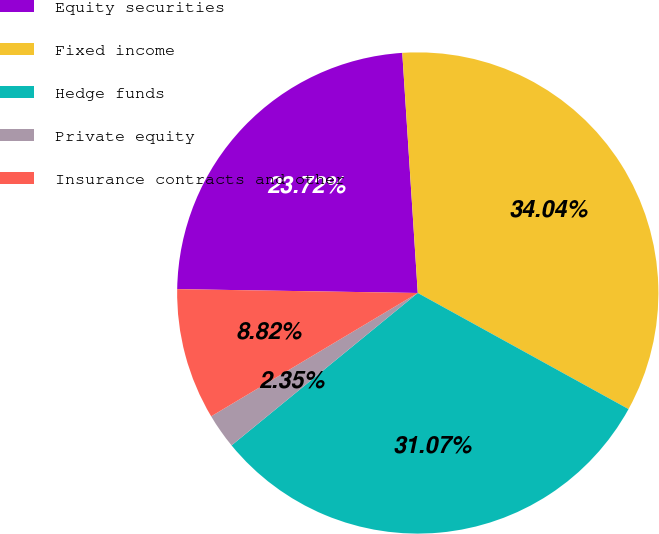<chart> <loc_0><loc_0><loc_500><loc_500><pie_chart><fcel>Equity securities<fcel>Fixed income<fcel>Hedge funds<fcel>Private equity<fcel>Insurance contracts and other<nl><fcel>23.72%<fcel>34.04%<fcel>31.07%<fcel>2.35%<fcel>8.82%<nl></chart> 